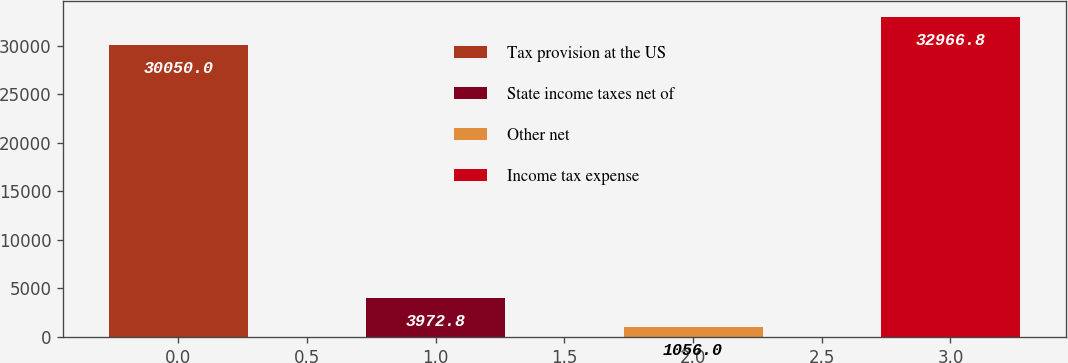Convert chart. <chart><loc_0><loc_0><loc_500><loc_500><bar_chart><fcel>Tax provision at the US<fcel>State income taxes net of<fcel>Other net<fcel>Income tax expense<nl><fcel>30050<fcel>3972.8<fcel>1056<fcel>32966.8<nl></chart> 